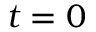Convert formula to latex. <formula><loc_0><loc_0><loc_500><loc_500>t = 0</formula> 